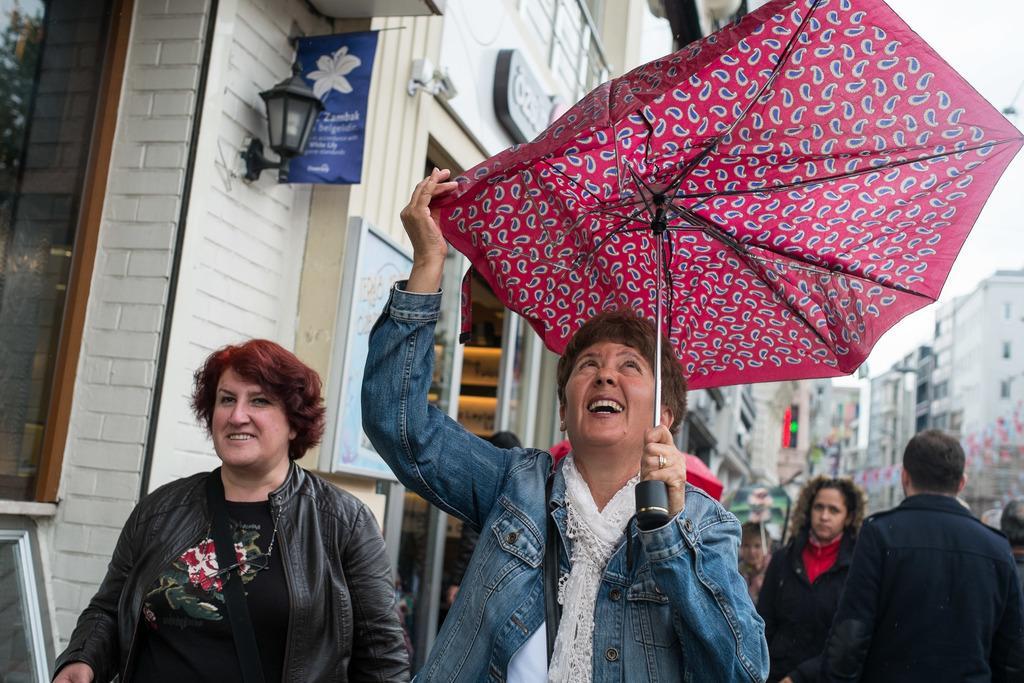Describe this image in one or two sentences. In this image I can see a person holding an umbrella and she is smiling ,beside her I can see a woman and she also smiling and in the middle I can see the building and lamp attached to the building and in the bottom right I can see some persons and the sky. 